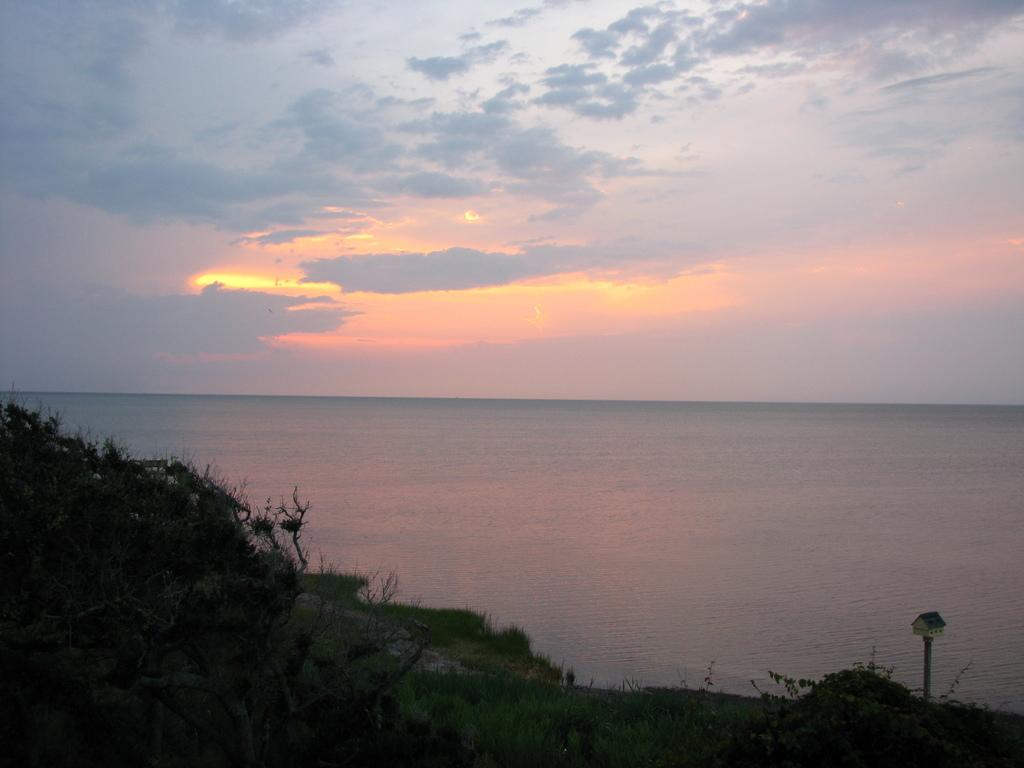What can be seen in the background of the image? There is water in the background of the image. What geographical feature is present in the image? There is a hill in the image. What type of vegetation is on the hill? Small plants are present on the hill. What is visible above the hill and water in the image? The sky is visible in the image. What can be observed in the sky? Clouds are present in the sky. Where is the lunchroom located in the image? There is no lunchroom present in the image; it features a hill, water, and sky. What type of pin can be seen holding up the clouds in the image? There is no pin holding up the clouds in the image; the clouds are a natural atmospheric phenomenon. 